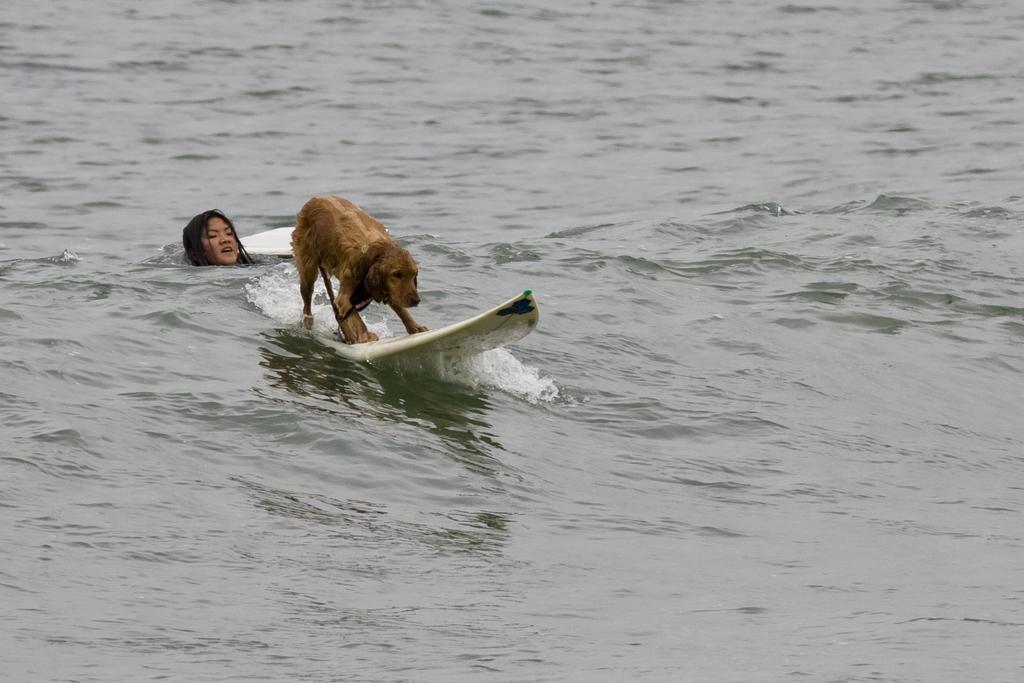How would you summarize this image in a sentence or two? In this image there is a dog on the surfboard and woman swimming in the water. In the background there is a water. 